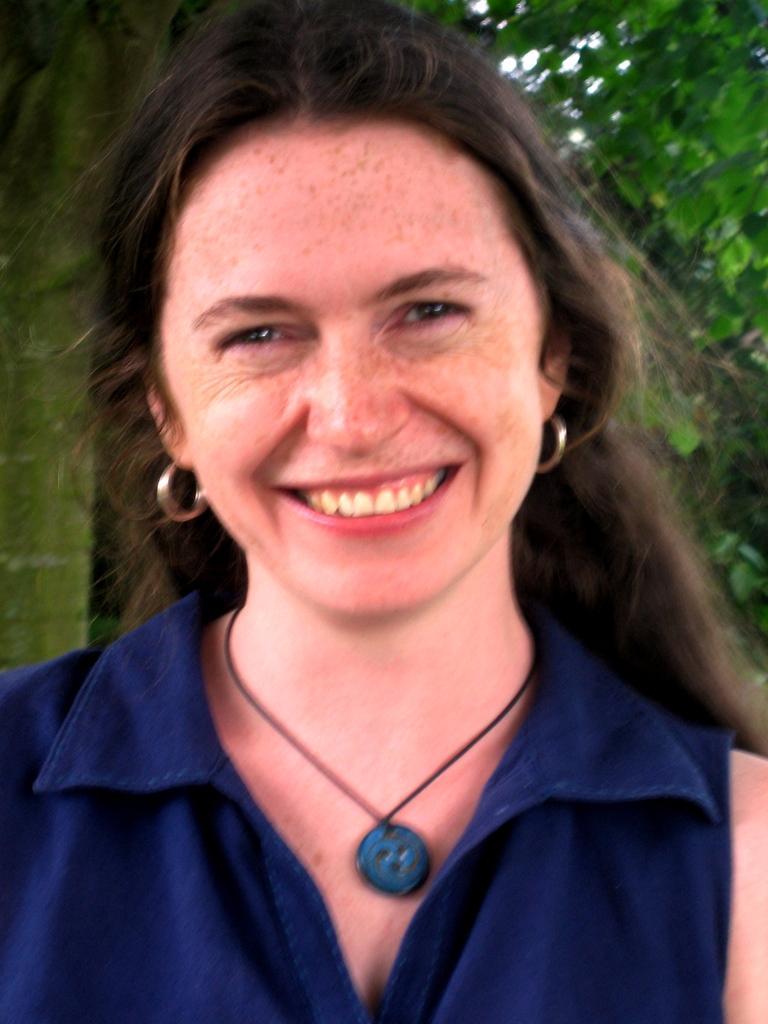Please provide a concise description of this image. In this image we can see a woman smiling, behind her we can see some trees and the sky. 